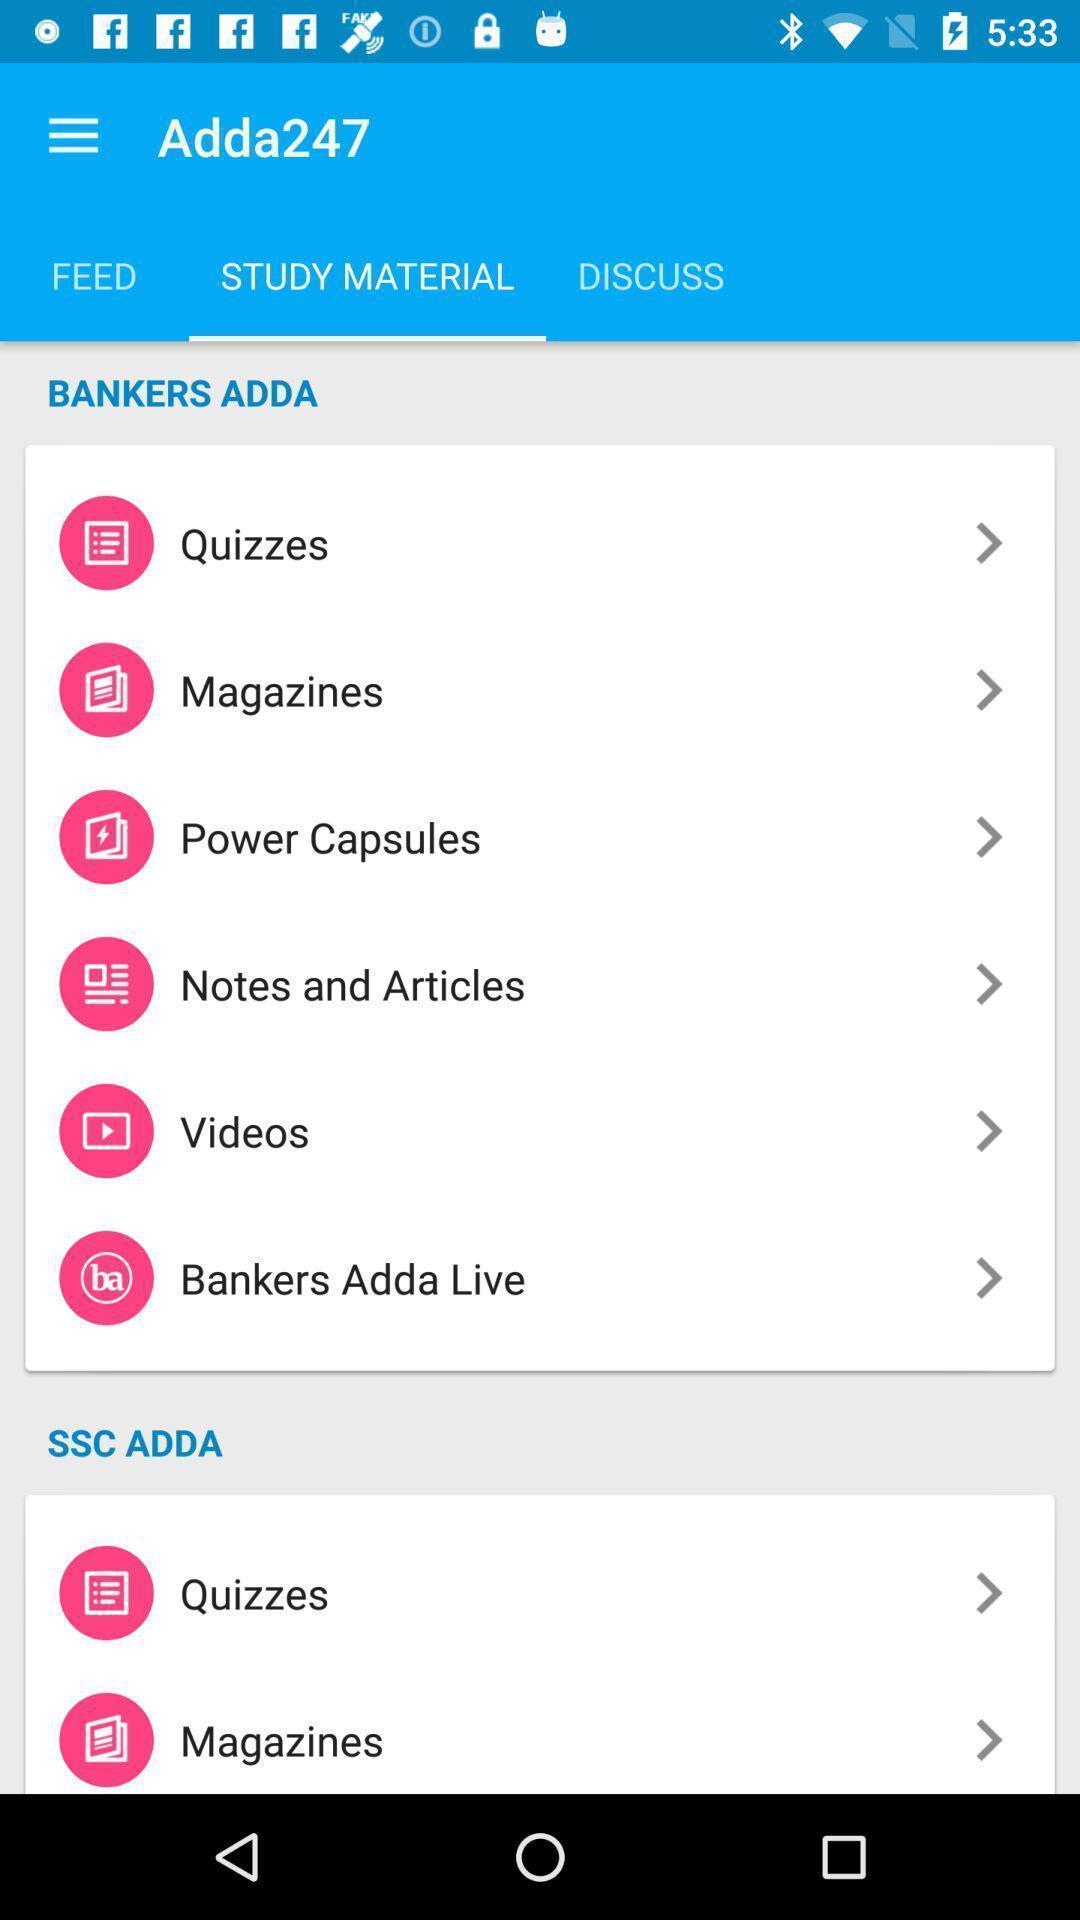Provide a textual representation of this image. Screen showing different study materials. 